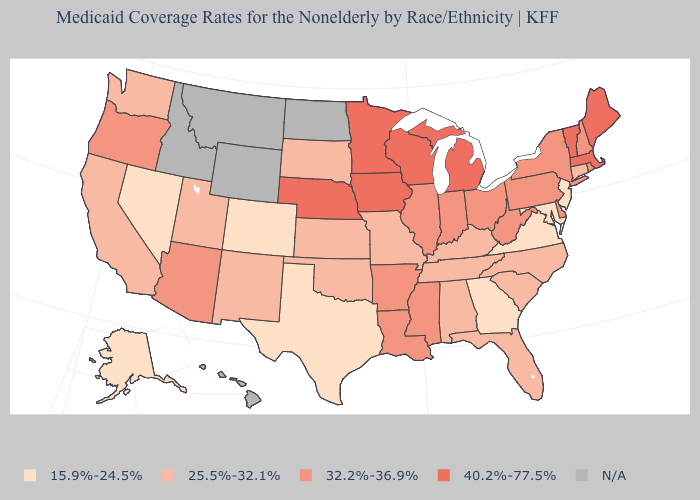Which states hav the highest value in the West?
Concise answer only. Arizona, Oregon. Does Maine have the highest value in the USA?
Be succinct. Yes. What is the value of Connecticut?
Short answer required. 25.5%-32.1%. Name the states that have a value in the range 40.2%-77.5%?
Keep it brief. Iowa, Maine, Massachusetts, Michigan, Minnesota, Nebraska, Vermont, Wisconsin. What is the value of Texas?
Write a very short answer. 15.9%-24.5%. Which states have the lowest value in the MidWest?
Keep it brief. Kansas, Missouri, South Dakota. Does Colorado have the highest value in the West?
Write a very short answer. No. Among the states that border Connecticut , which have the lowest value?
Write a very short answer. New York, Rhode Island. Name the states that have a value in the range 40.2%-77.5%?
Be succinct. Iowa, Maine, Massachusetts, Michigan, Minnesota, Nebraska, Vermont, Wisconsin. What is the highest value in states that border Washington?
Give a very brief answer. 32.2%-36.9%. Name the states that have a value in the range 40.2%-77.5%?
Concise answer only. Iowa, Maine, Massachusetts, Michigan, Minnesota, Nebraska, Vermont, Wisconsin. What is the value of Maryland?
Keep it brief. 15.9%-24.5%. How many symbols are there in the legend?
Quick response, please. 5. What is the lowest value in the USA?
Write a very short answer. 15.9%-24.5%. 